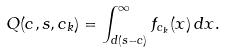Convert formula to latex. <formula><loc_0><loc_0><loc_500><loc_500>Q ( { c } , { s } , { c } _ { k } ) = \int _ { d ( { s - c } ) } ^ { \infty } f _ { { c } _ { k } } ( x ) \, d x .</formula> 